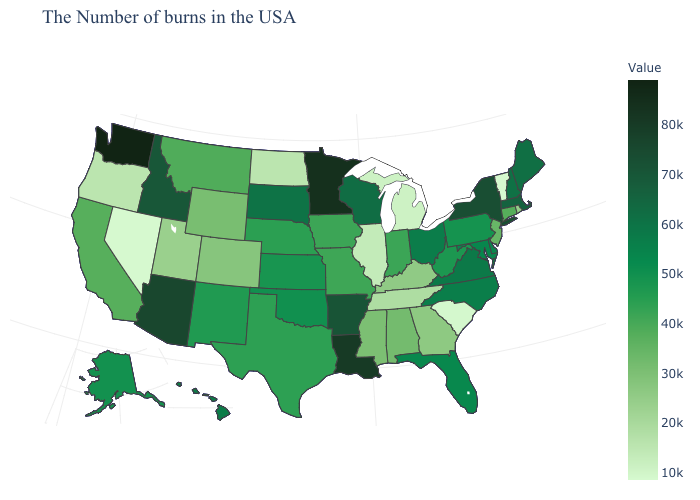Among the states that border Minnesota , which have the lowest value?
Keep it brief. North Dakota. Does Nevada have the highest value in the USA?
Quick response, please. No. Does Washington have the highest value in the West?
Concise answer only. Yes. Among the states that border Wisconsin , which have the highest value?
Answer briefly. Minnesota. Does the map have missing data?
Keep it brief. No. Does Hawaii have the highest value in the West?
Give a very brief answer. No. 